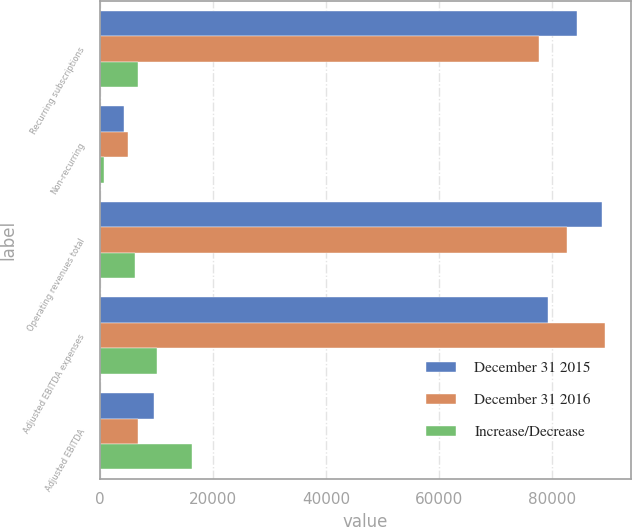Convert chart. <chart><loc_0><loc_0><loc_500><loc_500><stacked_bar_chart><ecel><fcel>Recurring subscriptions<fcel>Non-recurring<fcel>Operating revenues total<fcel>Adjusted EBITDA expenses<fcel>Adjusted EBITDA<nl><fcel>December 31 2015<fcel>84457<fcel>4308<fcel>88765<fcel>79293<fcel>9472<nl><fcel>December 31 2016<fcel>77666<fcel>4959<fcel>82625<fcel>89383<fcel>6758<nl><fcel>Increase/Decrease<fcel>6791<fcel>651<fcel>6140<fcel>10090<fcel>16230<nl></chart> 